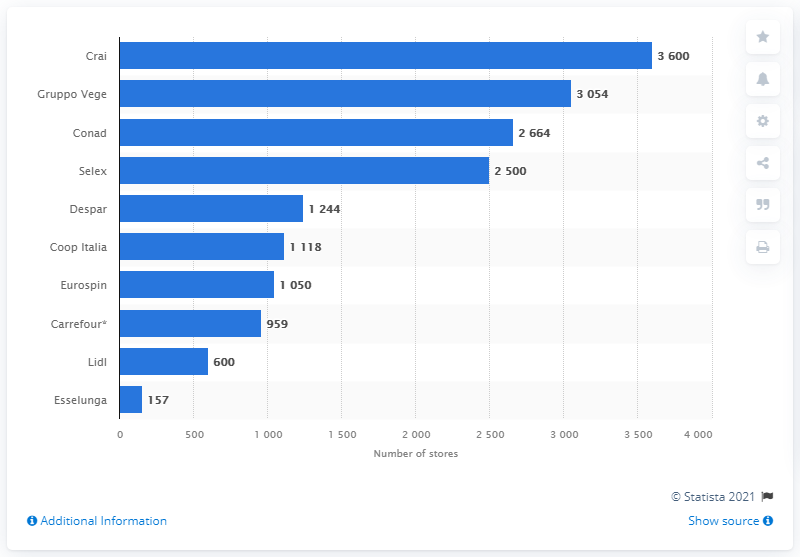Point out several critical features in this image. Crai has 3,600 stores. In 2018, the leading retailer in Italy in terms of the number of stores was Crai. In 2017, Conad was the second largest supermarket chain in Italy. 